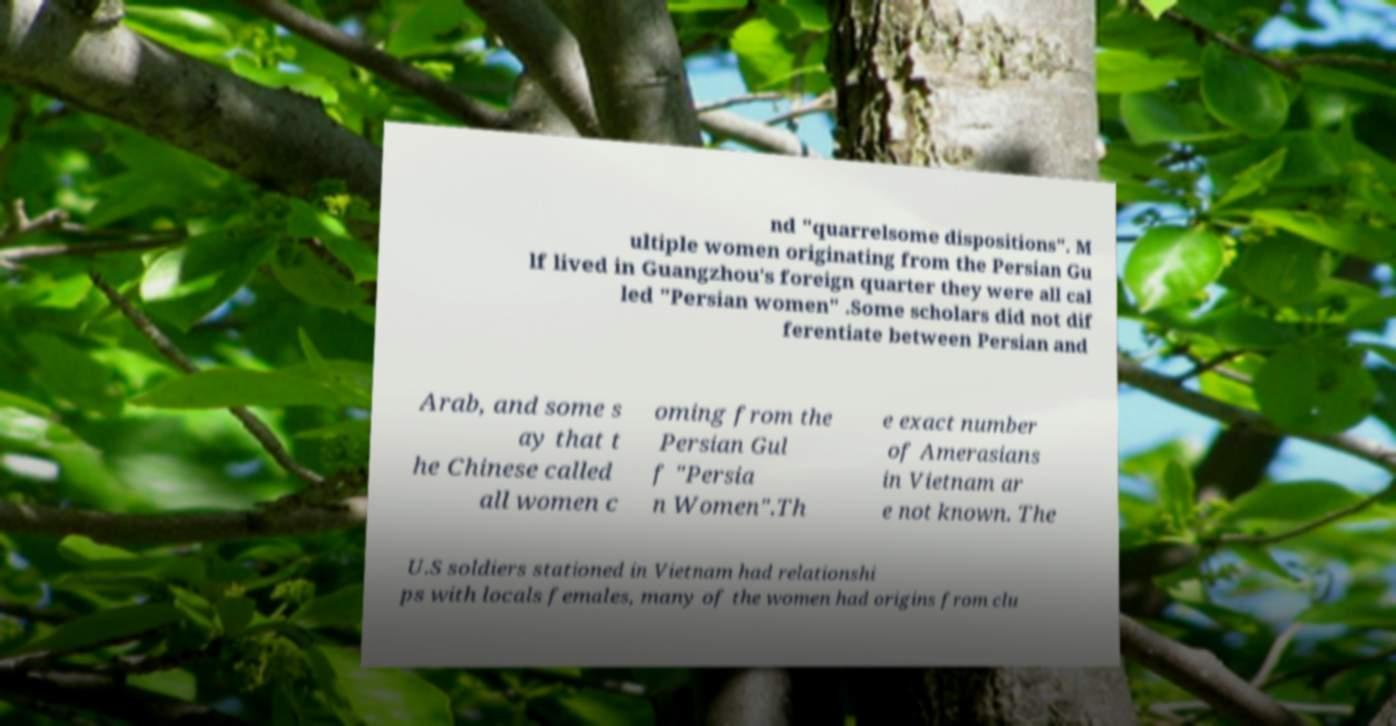Please read and relay the text visible in this image. What does it say? nd "quarrelsome dispositions". M ultiple women originating from the Persian Gu lf lived in Guangzhou's foreign quarter they were all cal led "Persian women" .Some scholars did not dif ferentiate between Persian and Arab, and some s ay that t he Chinese called all women c oming from the Persian Gul f "Persia n Women".Th e exact number of Amerasians in Vietnam ar e not known. The U.S soldiers stationed in Vietnam had relationshi ps with locals females, many of the women had origins from clu 